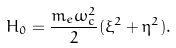<formula> <loc_0><loc_0><loc_500><loc_500>H _ { 0 } = \frac { m _ { e } \omega _ { c } ^ { 2 } } { 2 } ( \xi ^ { 2 } + \eta ^ { 2 } ) .</formula> 